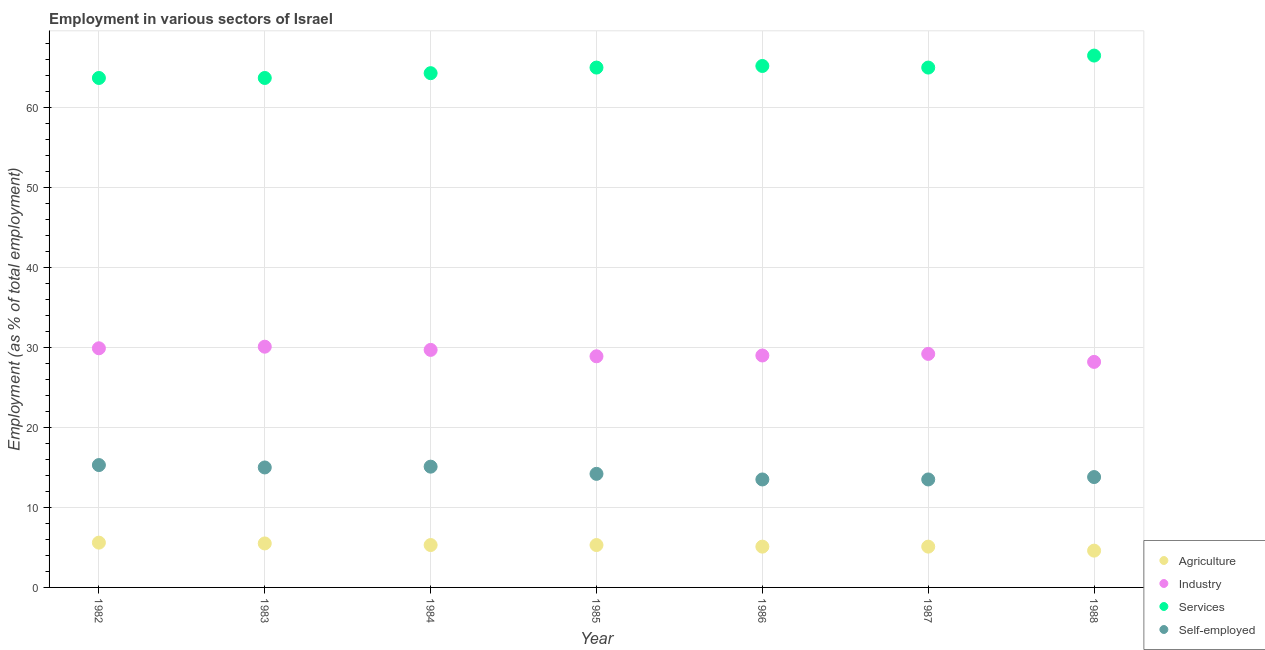What is the percentage of workers in industry in 1984?
Provide a succinct answer. 29.7. Across all years, what is the maximum percentage of workers in services?
Your answer should be compact. 66.5. Across all years, what is the minimum percentage of workers in industry?
Your response must be concise. 28.2. In which year was the percentage of workers in industry maximum?
Your answer should be compact. 1983. What is the total percentage of workers in industry in the graph?
Make the answer very short. 205. What is the difference between the percentage of self employed workers in 1985 and that in 1987?
Make the answer very short. 0.7. What is the difference between the percentage of workers in services in 1987 and the percentage of self employed workers in 1986?
Offer a terse response. 51.5. What is the average percentage of workers in agriculture per year?
Ensure brevity in your answer.  5.21. In the year 1988, what is the difference between the percentage of workers in agriculture and percentage of workers in services?
Your response must be concise. -61.9. What is the ratio of the percentage of workers in services in 1986 to that in 1988?
Your response must be concise. 0.98. Is the percentage of workers in services in 1984 less than that in 1988?
Provide a succinct answer. Yes. Is the difference between the percentage of self employed workers in 1984 and 1987 greater than the difference between the percentage of workers in services in 1984 and 1987?
Your response must be concise. Yes. What is the difference between the highest and the second highest percentage of workers in agriculture?
Ensure brevity in your answer.  0.1. What is the difference between the highest and the lowest percentage of workers in industry?
Keep it short and to the point. 1.9. In how many years, is the percentage of self employed workers greater than the average percentage of self employed workers taken over all years?
Your response must be concise. 3. Is the sum of the percentage of workers in agriculture in 1983 and 1988 greater than the maximum percentage of self employed workers across all years?
Offer a terse response. No. Is the percentage of self employed workers strictly greater than the percentage of workers in agriculture over the years?
Your answer should be very brief. Yes. Are the values on the major ticks of Y-axis written in scientific E-notation?
Provide a succinct answer. No. Does the graph contain grids?
Offer a terse response. Yes. How many legend labels are there?
Offer a terse response. 4. What is the title of the graph?
Offer a very short reply. Employment in various sectors of Israel. What is the label or title of the X-axis?
Offer a terse response. Year. What is the label or title of the Y-axis?
Your answer should be very brief. Employment (as % of total employment). What is the Employment (as % of total employment) of Agriculture in 1982?
Ensure brevity in your answer.  5.6. What is the Employment (as % of total employment) in Industry in 1982?
Your answer should be compact. 29.9. What is the Employment (as % of total employment) of Services in 1982?
Ensure brevity in your answer.  63.7. What is the Employment (as % of total employment) of Self-employed in 1982?
Keep it short and to the point. 15.3. What is the Employment (as % of total employment) of Industry in 1983?
Ensure brevity in your answer.  30.1. What is the Employment (as % of total employment) in Services in 1983?
Your answer should be compact. 63.7. What is the Employment (as % of total employment) in Agriculture in 1984?
Your answer should be compact. 5.3. What is the Employment (as % of total employment) in Industry in 1984?
Keep it short and to the point. 29.7. What is the Employment (as % of total employment) of Services in 1984?
Make the answer very short. 64.3. What is the Employment (as % of total employment) in Self-employed in 1984?
Offer a terse response. 15.1. What is the Employment (as % of total employment) in Agriculture in 1985?
Ensure brevity in your answer.  5.3. What is the Employment (as % of total employment) in Industry in 1985?
Make the answer very short. 28.9. What is the Employment (as % of total employment) of Self-employed in 1985?
Your answer should be very brief. 14.2. What is the Employment (as % of total employment) of Agriculture in 1986?
Your response must be concise. 5.1. What is the Employment (as % of total employment) in Industry in 1986?
Keep it short and to the point. 29. What is the Employment (as % of total employment) of Services in 1986?
Ensure brevity in your answer.  65.2. What is the Employment (as % of total employment) in Self-employed in 1986?
Ensure brevity in your answer.  13.5. What is the Employment (as % of total employment) of Agriculture in 1987?
Keep it short and to the point. 5.1. What is the Employment (as % of total employment) of Industry in 1987?
Your answer should be very brief. 29.2. What is the Employment (as % of total employment) in Agriculture in 1988?
Provide a succinct answer. 4.6. What is the Employment (as % of total employment) of Industry in 1988?
Your response must be concise. 28.2. What is the Employment (as % of total employment) in Services in 1988?
Keep it short and to the point. 66.5. What is the Employment (as % of total employment) of Self-employed in 1988?
Your response must be concise. 13.8. Across all years, what is the maximum Employment (as % of total employment) in Agriculture?
Provide a short and direct response. 5.6. Across all years, what is the maximum Employment (as % of total employment) in Industry?
Your response must be concise. 30.1. Across all years, what is the maximum Employment (as % of total employment) in Services?
Give a very brief answer. 66.5. Across all years, what is the maximum Employment (as % of total employment) in Self-employed?
Ensure brevity in your answer.  15.3. Across all years, what is the minimum Employment (as % of total employment) in Agriculture?
Give a very brief answer. 4.6. Across all years, what is the minimum Employment (as % of total employment) of Industry?
Give a very brief answer. 28.2. Across all years, what is the minimum Employment (as % of total employment) of Services?
Provide a short and direct response. 63.7. Across all years, what is the minimum Employment (as % of total employment) in Self-employed?
Offer a very short reply. 13.5. What is the total Employment (as % of total employment) in Agriculture in the graph?
Make the answer very short. 36.5. What is the total Employment (as % of total employment) in Industry in the graph?
Offer a terse response. 205. What is the total Employment (as % of total employment) of Services in the graph?
Ensure brevity in your answer.  453.4. What is the total Employment (as % of total employment) of Self-employed in the graph?
Ensure brevity in your answer.  100.4. What is the difference between the Employment (as % of total employment) of Agriculture in 1982 and that in 1983?
Make the answer very short. 0.1. What is the difference between the Employment (as % of total employment) in Services in 1982 and that in 1983?
Give a very brief answer. 0. What is the difference between the Employment (as % of total employment) of Agriculture in 1982 and that in 1984?
Give a very brief answer. 0.3. What is the difference between the Employment (as % of total employment) of Industry in 1982 and that in 1984?
Keep it short and to the point. 0.2. What is the difference between the Employment (as % of total employment) of Services in 1982 and that in 1984?
Your answer should be compact. -0.6. What is the difference between the Employment (as % of total employment) in Services in 1982 and that in 1985?
Provide a succinct answer. -1.3. What is the difference between the Employment (as % of total employment) in Agriculture in 1982 and that in 1986?
Give a very brief answer. 0.5. What is the difference between the Employment (as % of total employment) in Industry in 1982 and that in 1986?
Make the answer very short. 0.9. What is the difference between the Employment (as % of total employment) of Agriculture in 1982 and that in 1987?
Give a very brief answer. 0.5. What is the difference between the Employment (as % of total employment) in Industry in 1982 and that in 1988?
Keep it short and to the point. 1.7. What is the difference between the Employment (as % of total employment) of Services in 1982 and that in 1988?
Offer a very short reply. -2.8. What is the difference between the Employment (as % of total employment) of Agriculture in 1983 and that in 1984?
Offer a very short reply. 0.2. What is the difference between the Employment (as % of total employment) of Industry in 1983 and that in 1984?
Keep it short and to the point. 0.4. What is the difference between the Employment (as % of total employment) of Services in 1983 and that in 1984?
Offer a very short reply. -0.6. What is the difference between the Employment (as % of total employment) in Agriculture in 1983 and that in 1985?
Offer a very short reply. 0.2. What is the difference between the Employment (as % of total employment) of Industry in 1983 and that in 1985?
Give a very brief answer. 1.2. What is the difference between the Employment (as % of total employment) in Agriculture in 1983 and that in 1986?
Keep it short and to the point. 0.4. What is the difference between the Employment (as % of total employment) of Services in 1983 and that in 1986?
Keep it short and to the point. -1.5. What is the difference between the Employment (as % of total employment) in Agriculture in 1983 and that in 1987?
Your answer should be very brief. 0.4. What is the difference between the Employment (as % of total employment) of Services in 1983 and that in 1987?
Provide a short and direct response. -1.3. What is the difference between the Employment (as % of total employment) in Self-employed in 1983 and that in 1987?
Your answer should be very brief. 1.5. What is the difference between the Employment (as % of total employment) in Services in 1983 and that in 1988?
Your answer should be very brief. -2.8. What is the difference between the Employment (as % of total employment) in Self-employed in 1983 and that in 1988?
Keep it short and to the point. 1.2. What is the difference between the Employment (as % of total employment) in Agriculture in 1984 and that in 1985?
Ensure brevity in your answer.  0. What is the difference between the Employment (as % of total employment) in Services in 1984 and that in 1985?
Your answer should be very brief. -0.7. What is the difference between the Employment (as % of total employment) in Self-employed in 1984 and that in 1985?
Provide a succinct answer. 0.9. What is the difference between the Employment (as % of total employment) of Agriculture in 1984 and that in 1986?
Make the answer very short. 0.2. What is the difference between the Employment (as % of total employment) in Industry in 1984 and that in 1986?
Offer a terse response. 0.7. What is the difference between the Employment (as % of total employment) of Services in 1984 and that in 1986?
Your response must be concise. -0.9. What is the difference between the Employment (as % of total employment) in Agriculture in 1984 and that in 1987?
Your response must be concise. 0.2. What is the difference between the Employment (as % of total employment) of Services in 1984 and that in 1988?
Your answer should be very brief. -2.2. What is the difference between the Employment (as % of total employment) of Self-employed in 1984 and that in 1988?
Provide a short and direct response. 1.3. What is the difference between the Employment (as % of total employment) in Industry in 1985 and that in 1986?
Your answer should be compact. -0.1. What is the difference between the Employment (as % of total employment) of Self-employed in 1985 and that in 1986?
Offer a very short reply. 0.7. What is the difference between the Employment (as % of total employment) in Agriculture in 1985 and that in 1987?
Make the answer very short. 0.2. What is the difference between the Employment (as % of total employment) in Agriculture in 1985 and that in 1988?
Your response must be concise. 0.7. What is the difference between the Employment (as % of total employment) of Industry in 1985 and that in 1988?
Your response must be concise. 0.7. What is the difference between the Employment (as % of total employment) in Self-employed in 1985 and that in 1988?
Offer a terse response. 0.4. What is the difference between the Employment (as % of total employment) in Agriculture in 1986 and that in 1988?
Provide a short and direct response. 0.5. What is the difference between the Employment (as % of total employment) in Industry in 1986 and that in 1988?
Your answer should be very brief. 0.8. What is the difference between the Employment (as % of total employment) in Services in 1986 and that in 1988?
Give a very brief answer. -1.3. What is the difference between the Employment (as % of total employment) of Agriculture in 1987 and that in 1988?
Ensure brevity in your answer.  0.5. What is the difference between the Employment (as % of total employment) of Services in 1987 and that in 1988?
Provide a succinct answer. -1.5. What is the difference between the Employment (as % of total employment) in Agriculture in 1982 and the Employment (as % of total employment) in Industry in 1983?
Give a very brief answer. -24.5. What is the difference between the Employment (as % of total employment) in Agriculture in 1982 and the Employment (as % of total employment) in Services in 1983?
Make the answer very short. -58.1. What is the difference between the Employment (as % of total employment) of Agriculture in 1982 and the Employment (as % of total employment) of Self-employed in 1983?
Your answer should be very brief. -9.4. What is the difference between the Employment (as % of total employment) in Industry in 1982 and the Employment (as % of total employment) in Services in 1983?
Offer a terse response. -33.8. What is the difference between the Employment (as % of total employment) in Services in 1982 and the Employment (as % of total employment) in Self-employed in 1983?
Provide a short and direct response. 48.7. What is the difference between the Employment (as % of total employment) of Agriculture in 1982 and the Employment (as % of total employment) of Industry in 1984?
Offer a very short reply. -24.1. What is the difference between the Employment (as % of total employment) of Agriculture in 1982 and the Employment (as % of total employment) of Services in 1984?
Provide a short and direct response. -58.7. What is the difference between the Employment (as % of total employment) in Industry in 1982 and the Employment (as % of total employment) in Services in 1984?
Keep it short and to the point. -34.4. What is the difference between the Employment (as % of total employment) of Services in 1982 and the Employment (as % of total employment) of Self-employed in 1984?
Offer a terse response. 48.6. What is the difference between the Employment (as % of total employment) of Agriculture in 1982 and the Employment (as % of total employment) of Industry in 1985?
Your response must be concise. -23.3. What is the difference between the Employment (as % of total employment) in Agriculture in 1982 and the Employment (as % of total employment) in Services in 1985?
Keep it short and to the point. -59.4. What is the difference between the Employment (as % of total employment) in Agriculture in 1982 and the Employment (as % of total employment) in Self-employed in 1985?
Ensure brevity in your answer.  -8.6. What is the difference between the Employment (as % of total employment) in Industry in 1982 and the Employment (as % of total employment) in Services in 1985?
Provide a succinct answer. -35.1. What is the difference between the Employment (as % of total employment) in Services in 1982 and the Employment (as % of total employment) in Self-employed in 1985?
Make the answer very short. 49.5. What is the difference between the Employment (as % of total employment) of Agriculture in 1982 and the Employment (as % of total employment) of Industry in 1986?
Ensure brevity in your answer.  -23.4. What is the difference between the Employment (as % of total employment) of Agriculture in 1982 and the Employment (as % of total employment) of Services in 1986?
Your response must be concise. -59.6. What is the difference between the Employment (as % of total employment) in Agriculture in 1982 and the Employment (as % of total employment) in Self-employed in 1986?
Provide a short and direct response. -7.9. What is the difference between the Employment (as % of total employment) in Industry in 1982 and the Employment (as % of total employment) in Services in 1986?
Your answer should be very brief. -35.3. What is the difference between the Employment (as % of total employment) of Industry in 1982 and the Employment (as % of total employment) of Self-employed in 1986?
Offer a very short reply. 16.4. What is the difference between the Employment (as % of total employment) in Services in 1982 and the Employment (as % of total employment) in Self-employed in 1986?
Make the answer very short. 50.2. What is the difference between the Employment (as % of total employment) in Agriculture in 1982 and the Employment (as % of total employment) in Industry in 1987?
Provide a succinct answer. -23.6. What is the difference between the Employment (as % of total employment) of Agriculture in 1982 and the Employment (as % of total employment) of Services in 1987?
Your response must be concise. -59.4. What is the difference between the Employment (as % of total employment) in Industry in 1982 and the Employment (as % of total employment) in Services in 1987?
Keep it short and to the point. -35.1. What is the difference between the Employment (as % of total employment) in Services in 1982 and the Employment (as % of total employment) in Self-employed in 1987?
Provide a short and direct response. 50.2. What is the difference between the Employment (as % of total employment) in Agriculture in 1982 and the Employment (as % of total employment) in Industry in 1988?
Your response must be concise. -22.6. What is the difference between the Employment (as % of total employment) in Agriculture in 1982 and the Employment (as % of total employment) in Services in 1988?
Give a very brief answer. -60.9. What is the difference between the Employment (as % of total employment) of Industry in 1982 and the Employment (as % of total employment) of Services in 1988?
Your answer should be compact. -36.6. What is the difference between the Employment (as % of total employment) in Industry in 1982 and the Employment (as % of total employment) in Self-employed in 1988?
Offer a terse response. 16.1. What is the difference between the Employment (as % of total employment) in Services in 1982 and the Employment (as % of total employment) in Self-employed in 1988?
Your response must be concise. 49.9. What is the difference between the Employment (as % of total employment) in Agriculture in 1983 and the Employment (as % of total employment) in Industry in 1984?
Your response must be concise. -24.2. What is the difference between the Employment (as % of total employment) in Agriculture in 1983 and the Employment (as % of total employment) in Services in 1984?
Your answer should be compact. -58.8. What is the difference between the Employment (as % of total employment) in Agriculture in 1983 and the Employment (as % of total employment) in Self-employed in 1984?
Offer a terse response. -9.6. What is the difference between the Employment (as % of total employment) in Industry in 1983 and the Employment (as % of total employment) in Services in 1984?
Offer a very short reply. -34.2. What is the difference between the Employment (as % of total employment) in Industry in 1983 and the Employment (as % of total employment) in Self-employed in 1984?
Provide a short and direct response. 15. What is the difference between the Employment (as % of total employment) of Services in 1983 and the Employment (as % of total employment) of Self-employed in 1984?
Your answer should be very brief. 48.6. What is the difference between the Employment (as % of total employment) of Agriculture in 1983 and the Employment (as % of total employment) of Industry in 1985?
Your answer should be very brief. -23.4. What is the difference between the Employment (as % of total employment) of Agriculture in 1983 and the Employment (as % of total employment) of Services in 1985?
Offer a very short reply. -59.5. What is the difference between the Employment (as % of total employment) of Agriculture in 1983 and the Employment (as % of total employment) of Self-employed in 1985?
Provide a short and direct response. -8.7. What is the difference between the Employment (as % of total employment) in Industry in 1983 and the Employment (as % of total employment) in Services in 1985?
Offer a very short reply. -34.9. What is the difference between the Employment (as % of total employment) in Services in 1983 and the Employment (as % of total employment) in Self-employed in 1985?
Give a very brief answer. 49.5. What is the difference between the Employment (as % of total employment) of Agriculture in 1983 and the Employment (as % of total employment) of Industry in 1986?
Provide a short and direct response. -23.5. What is the difference between the Employment (as % of total employment) of Agriculture in 1983 and the Employment (as % of total employment) of Services in 1986?
Ensure brevity in your answer.  -59.7. What is the difference between the Employment (as % of total employment) of Agriculture in 1983 and the Employment (as % of total employment) of Self-employed in 1986?
Offer a very short reply. -8. What is the difference between the Employment (as % of total employment) of Industry in 1983 and the Employment (as % of total employment) of Services in 1986?
Give a very brief answer. -35.1. What is the difference between the Employment (as % of total employment) in Services in 1983 and the Employment (as % of total employment) in Self-employed in 1986?
Your answer should be very brief. 50.2. What is the difference between the Employment (as % of total employment) of Agriculture in 1983 and the Employment (as % of total employment) of Industry in 1987?
Make the answer very short. -23.7. What is the difference between the Employment (as % of total employment) of Agriculture in 1983 and the Employment (as % of total employment) of Services in 1987?
Provide a succinct answer. -59.5. What is the difference between the Employment (as % of total employment) of Industry in 1983 and the Employment (as % of total employment) of Services in 1987?
Your answer should be very brief. -34.9. What is the difference between the Employment (as % of total employment) of Services in 1983 and the Employment (as % of total employment) of Self-employed in 1987?
Offer a very short reply. 50.2. What is the difference between the Employment (as % of total employment) in Agriculture in 1983 and the Employment (as % of total employment) in Industry in 1988?
Your answer should be very brief. -22.7. What is the difference between the Employment (as % of total employment) in Agriculture in 1983 and the Employment (as % of total employment) in Services in 1988?
Keep it short and to the point. -61. What is the difference between the Employment (as % of total employment) of Agriculture in 1983 and the Employment (as % of total employment) of Self-employed in 1988?
Give a very brief answer. -8.3. What is the difference between the Employment (as % of total employment) in Industry in 1983 and the Employment (as % of total employment) in Services in 1988?
Give a very brief answer. -36.4. What is the difference between the Employment (as % of total employment) of Industry in 1983 and the Employment (as % of total employment) of Self-employed in 1988?
Give a very brief answer. 16.3. What is the difference between the Employment (as % of total employment) of Services in 1983 and the Employment (as % of total employment) of Self-employed in 1988?
Your answer should be compact. 49.9. What is the difference between the Employment (as % of total employment) of Agriculture in 1984 and the Employment (as % of total employment) of Industry in 1985?
Provide a short and direct response. -23.6. What is the difference between the Employment (as % of total employment) of Agriculture in 1984 and the Employment (as % of total employment) of Services in 1985?
Offer a very short reply. -59.7. What is the difference between the Employment (as % of total employment) of Agriculture in 1984 and the Employment (as % of total employment) of Self-employed in 1985?
Keep it short and to the point. -8.9. What is the difference between the Employment (as % of total employment) of Industry in 1984 and the Employment (as % of total employment) of Services in 1985?
Provide a short and direct response. -35.3. What is the difference between the Employment (as % of total employment) in Services in 1984 and the Employment (as % of total employment) in Self-employed in 1985?
Provide a succinct answer. 50.1. What is the difference between the Employment (as % of total employment) in Agriculture in 1984 and the Employment (as % of total employment) in Industry in 1986?
Ensure brevity in your answer.  -23.7. What is the difference between the Employment (as % of total employment) in Agriculture in 1984 and the Employment (as % of total employment) in Services in 1986?
Offer a terse response. -59.9. What is the difference between the Employment (as % of total employment) in Agriculture in 1984 and the Employment (as % of total employment) in Self-employed in 1986?
Ensure brevity in your answer.  -8.2. What is the difference between the Employment (as % of total employment) of Industry in 1984 and the Employment (as % of total employment) of Services in 1986?
Your response must be concise. -35.5. What is the difference between the Employment (as % of total employment) in Services in 1984 and the Employment (as % of total employment) in Self-employed in 1986?
Keep it short and to the point. 50.8. What is the difference between the Employment (as % of total employment) of Agriculture in 1984 and the Employment (as % of total employment) of Industry in 1987?
Make the answer very short. -23.9. What is the difference between the Employment (as % of total employment) in Agriculture in 1984 and the Employment (as % of total employment) in Services in 1987?
Offer a very short reply. -59.7. What is the difference between the Employment (as % of total employment) of Agriculture in 1984 and the Employment (as % of total employment) of Self-employed in 1987?
Your answer should be compact. -8.2. What is the difference between the Employment (as % of total employment) in Industry in 1984 and the Employment (as % of total employment) in Services in 1987?
Give a very brief answer. -35.3. What is the difference between the Employment (as % of total employment) of Services in 1984 and the Employment (as % of total employment) of Self-employed in 1987?
Give a very brief answer. 50.8. What is the difference between the Employment (as % of total employment) of Agriculture in 1984 and the Employment (as % of total employment) of Industry in 1988?
Your answer should be compact. -22.9. What is the difference between the Employment (as % of total employment) of Agriculture in 1984 and the Employment (as % of total employment) of Services in 1988?
Make the answer very short. -61.2. What is the difference between the Employment (as % of total employment) of Industry in 1984 and the Employment (as % of total employment) of Services in 1988?
Your response must be concise. -36.8. What is the difference between the Employment (as % of total employment) in Services in 1984 and the Employment (as % of total employment) in Self-employed in 1988?
Your response must be concise. 50.5. What is the difference between the Employment (as % of total employment) of Agriculture in 1985 and the Employment (as % of total employment) of Industry in 1986?
Your answer should be very brief. -23.7. What is the difference between the Employment (as % of total employment) in Agriculture in 1985 and the Employment (as % of total employment) in Services in 1986?
Your response must be concise. -59.9. What is the difference between the Employment (as % of total employment) in Industry in 1985 and the Employment (as % of total employment) in Services in 1986?
Ensure brevity in your answer.  -36.3. What is the difference between the Employment (as % of total employment) of Industry in 1985 and the Employment (as % of total employment) of Self-employed in 1986?
Your response must be concise. 15.4. What is the difference between the Employment (as % of total employment) in Services in 1985 and the Employment (as % of total employment) in Self-employed in 1986?
Ensure brevity in your answer.  51.5. What is the difference between the Employment (as % of total employment) in Agriculture in 1985 and the Employment (as % of total employment) in Industry in 1987?
Keep it short and to the point. -23.9. What is the difference between the Employment (as % of total employment) in Agriculture in 1985 and the Employment (as % of total employment) in Services in 1987?
Your response must be concise. -59.7. What is the difference between the Employment (as % of total employment) in Industry in 1985 and the Employment (as % of total employment) in Services in 1987?
Make the answer very short. -36.1. What is the difference between the Employment (as % of total employment) in Services in 1985 and the Employment (as % of total employment) in Self-employed in 1987?
Your answer should be very brief. 51.5. What is the difference between the Employment (as % of total employment) of Agriculture in 1985 and the Employment (as % of total employment) of Industry in 1988?
Ensure brevity in your answer.  -22.9. What is the difference between the Employment (as % of total employment) in Agriculture in 1985 and the Employment (as % of total employment) in Services in 1988?
Offer a very short reply. -61.2. What is the difference between the Employment (as % of total employment) of Agriculture in 1985 and the Employment (as % of total employment) of Self-employed in 1988?
Your answer should be compact. -8.5. What is the difference between the Employment (as % of total employment) in Industry in 1985 and the Employment (as % of total employment) in Services in 1988?
Your response must be concise. -37.6. What is the difference between the Employment (as % of total employment) of Services in 1985 and the Employment (as % of total employment) of Self-employed in 1988?
Offer a very short reply. 51.2. What is the difference between the Employment (as % of total employment) of Agriculture in 1986 and the Employment (as % of total employment) of Industry in 1987?
Your answer should be compact. -24.1. What is the difference between the Employment (as % of total employment) of Agriculture in 1986 and the Employment (as % of total employment) of Services in 1987?
Your answer should be very brief. -59.9. What is the difference between the Employment (as % of total employment) in Industry in 1986 and the Employment (as % of total employment) in Services in 1987?
Offer a very short reply. -36. What is the difference between the Employment (as % of total employment) in Industry in 1986 and the Employment (as % of total employment) in Self-employed in 1987?
Offer a terse response. 15.5. What is the difference between the Employment (as % of total employment) of Services in 1986 and the Employment (as % of total employment) of Self-employed in 1987?
Ensure brevity in your answer.  51.7. What is the difference between the Employment (as % of total employment) in Agriculture in 1986 and the Employment (as % of total employment) in Industry in 1988?
Provide a short and direct response. -23.1. What is the difference between the Employment (as % of total employment) in Agriculture in 1986 and the Employment (as % of total employment) in Services in 1988?
Keep it short and to the point. -61.4. What is the difference between the Employment (as % of total employment) of Industry in 1986 and the Employment (as % of total employment) of Services in 1988?
Provide a short and direct response. -37.5. What is the difference between the Employment (as % of total employment) in Industry in 1986 and the Employment (as % of total employment) in Self-employed in 1988?
Ensure brevity in your answer.  15.2. What is the difference between the Employment (as % of total employment) of Services in 1986 and the Employment (as % of total employment) of Self-employed in 1988?
Ensure brevity in your answer.  51.4. What is the difference between the Employment (as % of total employment) of Agriculture in 1987 and the Employment (as % of total employment) of Industry in 1988?
Offer a terse response. -23.1. What is the difference between the Employment (as % of total employment) of Agriculture in 1987 and the Employment (as % of total employment) of Services in 1988?
Keep it short and to the point. -61.4. What is the difference between the Employment (as % of total employment) in Industry in 1987 and the Employment (as % of total employment) in Services in 1988?
Give a very brief answer. -37.3. What is the difference between the Employment (as % of total employment) of Services in 1987 and the Employment (as % of total employment) of Self-employed in 1988?
Your answer should be compact. 51.2. What is the average Employment (as % of total employment) in Agriculture per year?
Ensure brevity in your answer.  5.21. What is the average Employment (as % of total employment) in Industry per year?
Your response must be concise. 29.29. What is the average Employment (as % of total employment) of Services per year?
Your answer should be compact. 64.77. What is the average Employment (as % of total employment) of Self-employed per year?
Offer a terse response. 14.34. In the year 1982, what is the difference between the Employment (as % of total employment) of Agriculture and Employment (as % of total employment) of Industry?
Your response must be concise. -24.3. In the year 1982, what is the difference between the Employment (as % of total employment) in Agriculture and Employment (as % of total employment) in Services?
Your answer should be compact. -58.1. In the year 1982, what is the difference between the Employment (as % of total employment) in Industry and Employment (as % of total employment) in Services?
Provide a succinct answer. -33.8. In the year 1982, what is the difference between the Employment (as % of total employment) in Services and Employment (as % of total employment) in Self-employed?
Give a very brief answer. 48.4. In the year 1983, what is the difference between the Employment (as % of total employment) in Agriculture and Employment (as % of total employment) in Industry?
Ensure brevity in your answer.  -24.6. In the year 1983, what is the difference between the Employment (as % of total employment) in Agriculture and Employment (as % of total employment) in Services?
Provide a short and direct response. -58.2. In the year 1983, what is the difference between the Employment (as % of total employment) in Industry and Employment (as % of total employment) in Services?
Provide a succinct answer. -33.6. In the year 1983, what is the difference between the Employment (as % of total employment) in Services and Employment (as % of total employment) in Self-employed?
Your answer should be very brief. 48.7. In the year 1984, what is the difference between the Employment (as % of total employment) in Agriculture and Employment (as % of total employment) in Industry?
Ensure brevity in your answer.  -24.4. In the year 1984, what is the difference between the Employment (as % of total employment) in Agriculture and Employment (as % of total employment) in Services?
Offer a very short reply. -59. In the year 1984, what is the difference between the Employment (as % of total employment) in Agriculture and Employment (as % of total employment) in Self-employed?
Give a very brief answer. -9.8. In the year 1984, what is the difference between the Employment (as % of total employment) in Industry and Employment (as % of total employment) in Services?
Keep it short and to the point. -34.6. In the year 1984, what is the difference between the Employment (as % of total employment) of Industry and Employment (as % of total employment) of Self-employed?
Your answer should be very brief. 14.6. In the year 1984, what is the difference between the Employment (as % of total employment) in Services and Employment (as % of total employment) in Self-employed?
Provide a succinct answer. 49.2. In the year 1985, what is the difference between the Employment (as % of total employment) in Agriculture and Employment (as % of total employment) in Industry?
Ensure brevity in your answer.  -23.6. In the year 1985, what is the difference between the Employment (as % of total employment) in Agriculture and Employment (as % of total employment) in Services?
Make the answer very short. -59.7. In the year 1985, what is the difference between the Employment (as % of total employment) in Agriculture and Employment (as % of total employment) in Self-employed?
Offer a terse response. -8.9. In the year 1985, what is the difference between the Employment (as % of total employment) of Industry and Employment (as % of total employment) of Services?
Give a very brief answer. -36.1. In the year 1985, what is the difference between the Employment (as % of total employment) in Services and Employment (as % of total employment) in Self-employed?
Your answer should be very brief. 50.8. In the year 1986, what is the difference between the Employment (as % of total employment) in Agriculture and Employment (as % of total employment) in Industry?
Your answer should be very brief. -23.9. In the year 1986, what is the difference between the Employment (as % of total employment) in Agriculture and Employment (as % of total employment) in Services?
Offer a very short reply. -60.1. In the year 1986, what is the difference between the Employment (as % of total employment) in Agriculture and Employment (as % of total employment) in Self-employed?
Offer a terse response. -8.4. In the year 1986, what is the difference between the Employment (as % of total employment) of Industry and Employment (as % of total employment) of Services?
Your response must be concise. -36.2. In the year 1986, what is the difference between the Employment (as % of total employment) in Services and Employment (as % of total employment) in Self-employed?
Give a very brief answer. 51.7. In the year 1987, what is the difference between the Employment (as % of total employment) of Agriculture and Employment (as % of total employment) of Industry?
Offer a terse response. -24.1. In the year 1987, what is the difference between the Employment (as % of total employment) in Agriculture and Employment (as % of total employment) in Services?
Make the answer very short. -59.9. In the year 1987, what is the difference between the Employment (as % of total employment) of Industry and Employment (as % of total employment) of Services?
Give a very brief answer. -35.8. In the year 1987, what is the difference between the Employment (as % of total employment) of Industry and Employment (as % of total employment) of Self-employed?
Make the answer very short. 15.7. In the year 1987, what is the difference between the Employment (as % of total employment) of Services and Employment (as % of total employment) of Self-employed?
Offer a terse response. 51.5. In the year 1988, what is the difference between the Employment (as % of total employment) in Agriculture and Employment (as % of total employment) in Industry?
Your response must be concise. -23.6. In the year 1988, what is the difference between the Employment (as % of total employment) of Agriculture and Employment (as % of total employment) of Services?
Ensure brevity in your answer.  -61.9. In the year 1988, what is the difference between the Employment (as % of total employment) of Industry and Employment (as % of total employment) of Services?
Ensure brevity in your answer.  -38.3. In the year 1988, what is the difference between the Employment (as % of total employment) in Industry and Employment (as % of total employment) in Self-employed?
Provide a short and direct response. 14.4. In the year 1988, what is the difference between the Employment (as % of total employment) of Services and Employment (as % of total employment) of Self-employed?
Provide a succinct answer. 52.7. What is the ratio of the Employment (as % of total employment) of Agriculture in 1982 to that in 1983?
Your answer should be very brief. 1.02. What is the ratio of the Employment (as % of total employment) of Agriculture in 1982 to that in 1984?
Your answer should be compact. 1.06. What is the ratio of the Employment (as % of total employment) of Industry in 1982 to that in 1984?
Your answer should be compact. 1.01. What is the ratio of the Employment (as % of total employment) in Self-employed in 1982 to that in 1984?
Make the answer very short. 1.01. What is the ratio of the Employment (as % of total employment) of Agriculture in 1982 to that in 1985?
Provide a succinct answer. 1.06. What is the ratio of the Employment (as % of total employment) of Industry in 1982 to that in 1985?
Offer a very short reply. 1.03. What is the ratio of the Employment (as % of total employment) of Services in 1982 to that in 1985?
Keep it short and to the point. 0.98. What is the ratio of the Employment (as % of total employment) in Self-employed in 1982 to that in 1985?
Offer a terse response. 1.08. What is the ratio of the Employment (as % of total employment) of Agriculture in 1982 to that in 1986?
Give a very brief answer. 1.1. What is the ratio of the Employment (as % of total employment) in Industry in 1982 to that in 1986?
Your answer should be very brief. 1.03. What is the ratio of the Employment (as % of total employment) in Self-employed in 1982 to that in 1986?
Your answer should be compact. 1.13. What is the ratio of the Employment (as % of total employment) of Agriculture in 1982 to that in 1987?
Your answer should be compact. 1.1. What is the ratio of the Employment (as % of total employment) of Self-employed in 1982 to that in 1987?
Offer a very short reply. 1.13. What is the ratio of the Employment (as % of total employment) in Agriculture in 1982 to that in 1988?
Keep it short and to the point. 1.22. What is the ratio of the Employment (as % of total employment) of Industry in 1982 to that in 1988?
Offer a very short reply. 1.06. What is the ratio of the Employment (as % of total employment) in Services in 1982 to that in 1988?
Your answer should be compact. 0.96. What is the ratio of the Employment (as % of total employment) of Self-employed in 1982 to that in 1988?
Offer a terse response. 1.11. What is the ratio of the Employment (as % of total employment) in Agriculture in 1983 to that in 1984?
Your answer should be very brief. 1.04. What is the ratio of the Employment (as % of total employment) in Industry in 1983 to that in 1984?
Your response must be concise. 1.01. What is the ratio of the Employment (as % of total employment) of Services in 1983 to that in 1984?
Provide a short and direct response. 0.99. What is the ratio of the Employment (as % of total employment) in Agriculture in 1983 to that in 1985?
Give a very brief answer. 1.04. What is the ratio of the Employment (as % of total employment) in Industry in 1983 to that in 1985?
Keep it short and to the point. 1.04. What is the ratio of the Employment (as % of total employment) in Self-employed in 1983 to that in 1985?
Offer a terse response. 1.06. What is the ratio of the Employment (as % of total employment) in Agriculture in 1983 to that in 1986?
Provide a succinct answer. 1.08. What is the ratio of the Employment (as % of total employment) of Industry in 1983 to that in 1986?
Your answer should be very brief. 1.04. What is the ratio of the Employment (as % of total employment) of Agriculture in 1983 to that in 1987?
Make the answer very short. 1.08. What is the ratio of the Employment (as % of total employment) in Industry in 1983 to that in 1987?
Provide a short and direct response. 1.03. What is the ratio of the Employment (as % of total employment) of Services in 1983 to that in 1987?
Offer a very short reply. 0.98. What is the ratio of the Employment (as % of total employment) in Self-employed in 1983 to that in 1987?
Offer a terse response. 1.11. What is the ratio of the Employment (as % of total employment) of Agriculture in 1983 to that in 1988?
Ensure brevity in your answer.  1.2. What is the ratio of the Employment (as % of total employment) in Industry in 1983 to that in 1988?
Offer a terse response. 1.07. What is the ratio of the Employment (as % of total employment) of Services in 1983 to that in 1988?
Your answer should be very brief. 0.96. What is the ratio of the Employment (as % of total employment) of Self-employed in 1983 to that in 1988?
Give a very brief answer. 1.09. What is the ratio of the Employment (as % of total employment) of Agriculture in 1984 to that in 1985?
Offer a terse response. 1. What is the ratio of the Employment (as % of total employment) in Industry in 1984 to that in 1985?
Your response must be concise. 1.03. What is the ratio of the Employment (as % of total employment) in Services in 1984 to that in 1985?
Keep it short and to the point. 0.99. What is the ratio of the Employment (as % of total employment) in Self-employed in 1984 to that in 1985?
Offer a very short reply. 1.06. What is the ratio of the Employment (as % of total employment) in Agriculture in 1984 to that in 1986?
Ensure brevity in your answer.  1.04. What is the ratio of the Employment (as % of total employment) in Industry in 1984 to that in 1986?
Give a very brief answer. 1.02. What is the ratio of the Employment (as % of total employment) in Services in 1984 to that in 1986?
Provide a short and direct response. 0.99. What is the ratio of the Employment (as % of total employment) in Self-employed in 1984 to that in 1986?
Offer a terse response. 1.12. What is the ratio of the Employment (as % of total employment) in Agriculture in 1984 to that in 1987?
Make the answer very short. 1.04. What is the ratio of the Employment (as % of total employment) of Industry in 1984 to that in 1987?
Offer a terse response. 1.02. What is the ratio of the Employment (as % of total employment) of Self-employed in 1984 to that in 1987?
Offer a terse response. 1.12. What is the ratio of the Employment (as % of total employment) of Agriculture in 1984 to that in 1988?
Your answer should be very brief. 1.15. What is the ratio of the Employment (as % of total employment) of Industry in 1984 to that in 1988?
Provide a succinct answer. 1.05. What is the ratio of the Employment (as % of total employment) in Services in 1984 to that in 1988?
Provide a succinct answer. 0.97. What is the ratio of the Employment (as % of total employment) in Self-employed in 1984 to that in 1988?
Offer a terse response. 1.09. What is the ratio of the Employment (as % of total employment) of Agriculture in 1985 to that in 1986?
Keep it short and to the point. 1.04. What is the ratio of the Employment (as % of total employment) of Services in 1985 to that in 1986?
Your response must be concise. 1. What is the ratio of the Employment (as % of total employment) in Self-employed in 1985 to that in 1986?
Give a very brief answer. 1.05. What is the ratio of the Employment (as % of total employment) of Agriculture in 1985 to that in 1987?
Offer a very short reply. 1.04. What is the ratio of the Employment (as % of total employment) of Self-employed in 1985 to that in 1987?
Keep it short and to the point. 1.05. What is the ratio of the Employment (as % of total employment) in Agriculture in 1985 to that in 1988?
Your answer should be very brief. 1.15. What is the ratio of the Employment (as % of total employment) in Industry in 1985 to that in 1988?
Offer a terse response. 1.02. What is the ratio of the Employment (as % of total employment) in Services in 1985 to that in 1988?
Provide a succinct answer. 0.98. What is the ratio of the Employment (as % of total employment) of Self-employed in 1985 to that in 1988?
Give a very brief answer. 1.03. What is the ratio of the Employment (as % of total employment) in Industry in 1986 to that in 1987?
Ensure brevity in your answer.  0.99. What is the ratio of the Employment (as % of total employment) of Self-employed in 1986 to that in 1987?
Ensure brevity in your answer.  1. What is the ratio of the Employment (as % of total employment) of Agriculture in 1986 to that in 1988?
Provide a short and direct response. 1.11. What is the ratio of the Employment (as % of total employment) of Industry in 1986 to that in 1988?
Ensure brevity in your answer.  1.03. What is the ratio of the Employment (as % of total employment) in Services in 1986 to that in 1988?
Your answer should be very brief. 0.98. What is the ratio of the Employment (as % of total employment) in Self-employed in 1986 to that in 1988?
Make the answer very short. 0.98. What is the ratio of the Employment (as % of total employment) of Agriculture in 1987 to that in 1988?
Offer a very short reply. 1.11. What is the ratio of the Employment (as % of total employment) of Industry in 1987 to that in 1988?
Your response must be concise. 1.04. What is the ratio of the Employment (as % of total employment) in Services in 1987 to that in 1988?
Provide a short and direct response. 0.98. What is the ratio of the Employment (as % of total employment) of Self-employed in 1987 to that in 1988?
Ensure brevity in your answer.  0.98. What is the difference between the highest and the second highest Employment (as % of total employment) of Agriculture?
Provide a succinct answer. 0.1. What is the difference between the highest and the second highest Employment (as % of total employment) in Industry?
Provide a succinct answer. 0.2. What is the difference between the highest and the lowest Employment (as % of total employment) of Self-employed?
Offer a terse response. 1.8. 